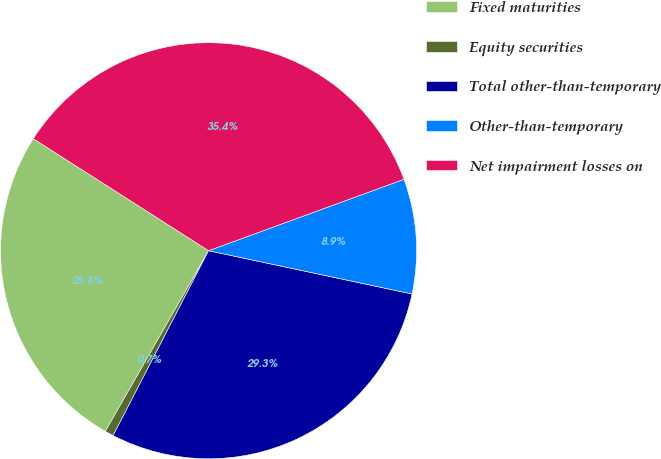Convert chart to OTSL. <chart><loc_0><loc_0><loc_500><loc_500><pie_chart><fcel>Fixed maturities<fcel>Equity securities<fcel>Total other-than-temporary<fcel>Other-than-temporary<fcel>Net impairment losses on<nl><fcel>25.78%<fcel>0.68%<fcel>29.25%<fcel>8.91%<fcel>35.37%<nl></chart> 